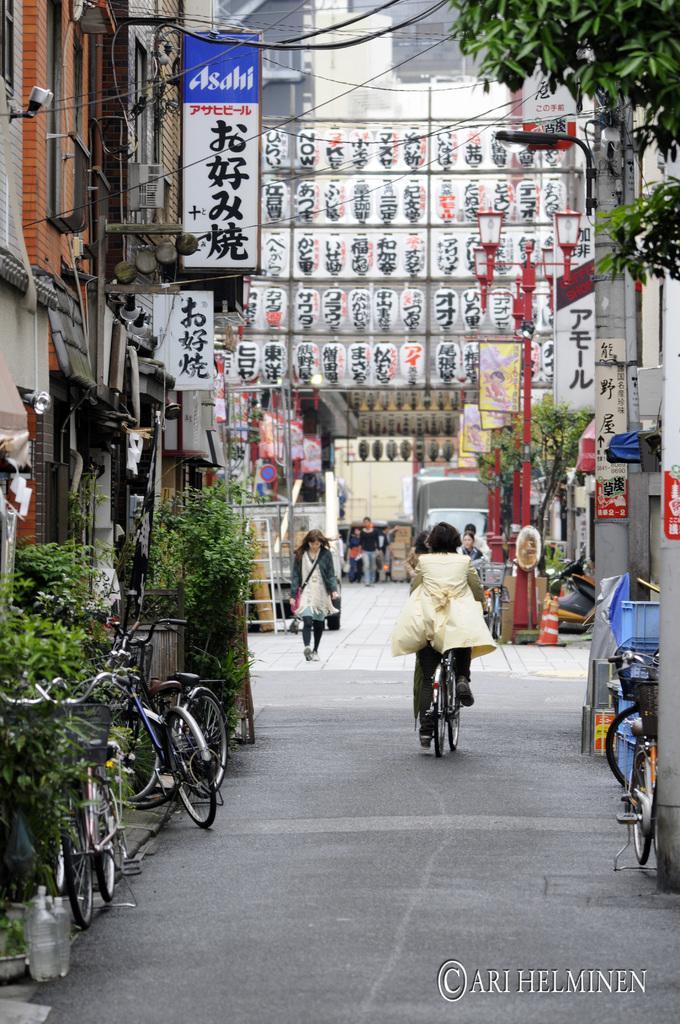Describe this image in one or two sentences. This picture is of outside. In the center there is a woman riding bicycle on the ground and in the left there is a woman wearing white color dress and walking. In the left corner we can see the bicycles, plants building, board. In the background we can see the buildings and poles of street lights. 